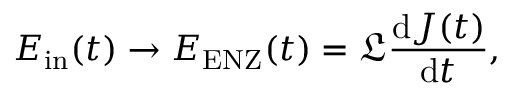Convert formula to latex. <formula><loc_0><loc_0><loc_500><loc_500>E _ { i n } ( t ) \to E _ { E N Z } ( t ) = \mathfrak { L } \frac { d J ( t ) } { d t } ,</formula> 